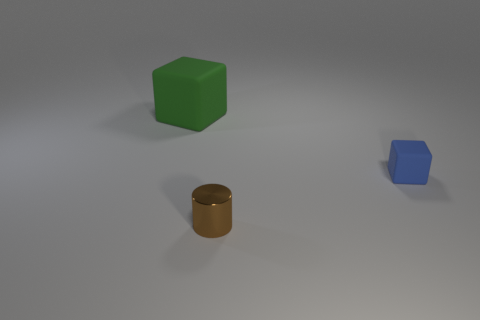What shape is the small blue object that is the same material as the green block?
Your answer should be compact. Cube. What is the color of the object that is both in front of the big green rubber block and behind the brown metal cylinder?
Give a very brief answer. Blue. Is the material of the small object that is in front of the small block the same as the small blue cube?
Provide a short and direct response. No. Are there fewer tiny shiny objects left of the tiny metal cylinder than tiny brown blocks?
Provide a succinct answer. No. Is there a yellow cube made of the same material as the large object?
Ensure brevity in your answer.  No. Do the metal cylinder and the cube behind the small matte block have the same size?
Ensure brevity in your answer.  No. Are there any other tiny matte blocks that have the same color as the small block?
Provide a succinct answer. No. Is the blue block made of the same material as the green thing?
Your answer should be very brief. Yes. How many blue matte blocks are to the left of the shiny cylinder?
Keep it short and to the point. 0. What material is the thing that is both in front of the large object and behind the tiny cylinder?
Give a very brief answer. Rubber. 